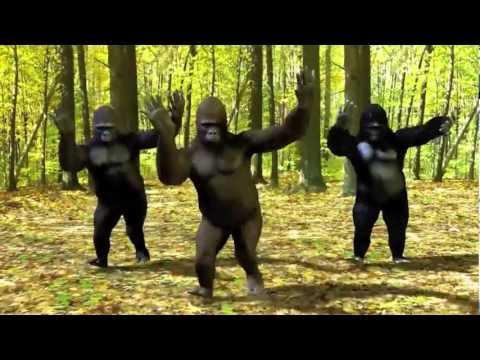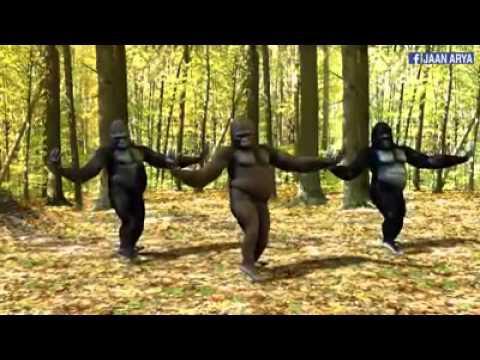The first image is the image on the left, the second image is the image on the right. Assess this claim about the two images: "The left and right image contains the same number of real breathing gorillas.". Correct or not? Answer yes or no. No. The first image is the image on the left, the second image is the image on the right. Assess this claim about the two images: "There are six gorillas tht are sitting". Correct or not? Answer yes or no. No. 